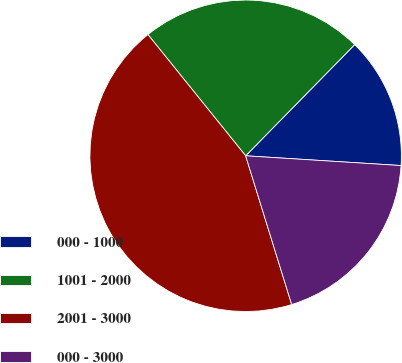Convert chart. <chart><loc_0><loc_0><loc_500><loc_500><pie_chart><fcel>000 - 1000<fcel>1001 - 2000<fcel>2001 - 3000<fcel>000 - 3000<nl><fcel>13.65%<fcel>23.14%<fcel>43.98%<fcel>19.22%<nl></chart> 